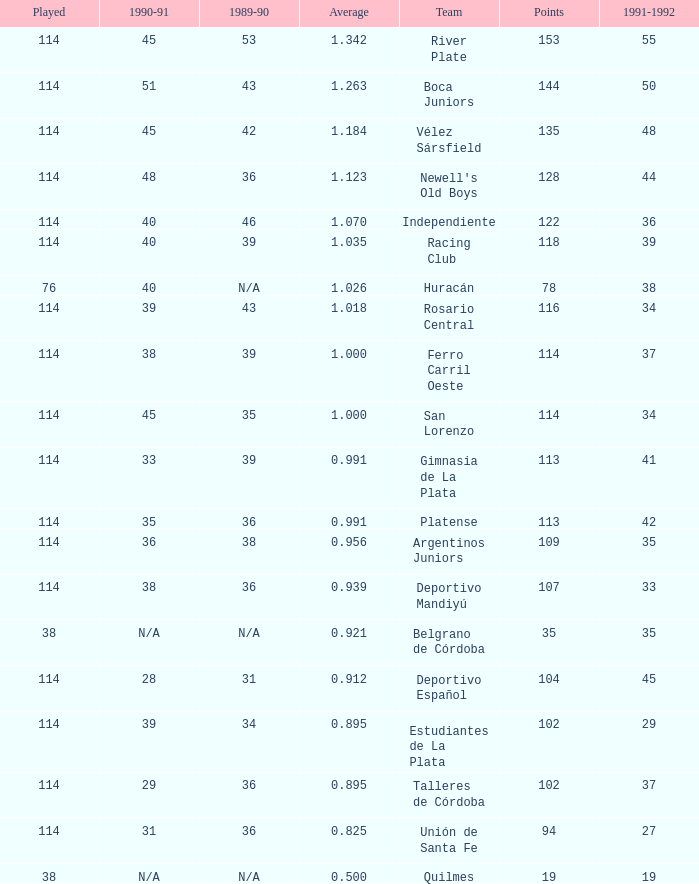How much 1991-1992 has a 1989-90 of 36, and an Average of 0.8250000000000001? 0.0. Would you be able to parse every entry in this table? {'header': ['Played', '1990-91', '1989-90', 'Average', 'Team', 'Points', '1991-1992'], 'rows': [['114', '45', '53', '1.342', 'River Plate', '153', '55'], ['114', '51', '43', '1.263', 'Boca Juniors', '144', '50'], ['114', '45', '42', '1.184', 'Vélez Sársfield', '135', '48'], ['114', '48', '36', '1.123', "Newell's Old Boys", '128', '44'], ['114', '40', '46', '1.070', 'Independiente', '122', '36'], ['114', '40', '39', '1.035', 'Racing Club', '118', '39'], ['76', '40', 'N/A', '1.026', 'Huracán', '78', '38'], ['114', '39', '43', '1.018', 'Rosario Central', '116', '34'], ['114', '38', '39', '1.000', 'Ferro Carril Oeste', '114', '37'], ['114', '45', '35', '1.000', 'San Lorenzo', '114', '34'], ['114', '33', '39', '0.991', 'Gimnasia de La Plata', '113', '41'], ['114', '35', '36', '0.991', 'Platense', '113', '42'], ['114', '36', '38', '0.956', 'Argentinos Juniors', '109', '35'], ['114', '38', '36', '0.939', 'Deportivo Mandiyú', '107', '33'], ['38', 'N/A', 'N/A', '0.921', 'Belgrano de Córdoba', '35', '35'], ['114', '28', '31', '0.912', 'Deportivo Español', '104', '45'], ['114', '39', '34', '0.895', 'Estudiantes de La Plata', '102', '29'], ['114', '29', '36', '0.895', 'Talleres de Córdoba', '102', '37'], ['114', '31', '36', '0.825', 'Unión de Santa Fe', '94', '27'], ['38', 'N/A', 'N/A', '0.500', 'Quilmes', '19', '19']]} 